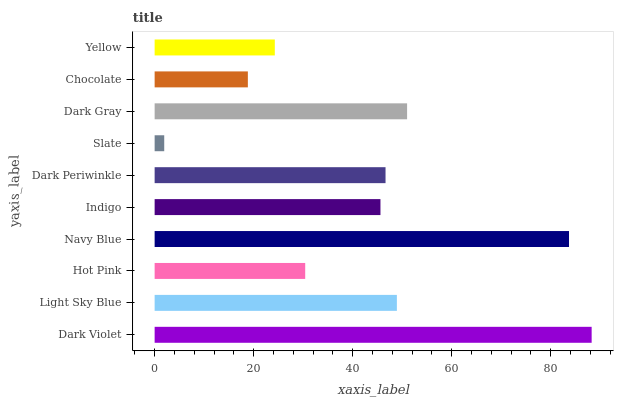Is Slate the minimum?
Answer yes or no. Yes. Is Dark Violet the maximum?
Answer yes or no. Yes. Is Light Sky Blue the minimum?
Answer yes or no. No. Is Light Sky Blue the maximum?
Answer yes or no. No. Is Dark Violet greater than Light Sky Blue?
Answer yes or no. Yes. Is Light Sky Blue less than Dark Violet?
Answer yes or no. Yes. Is Light Sky Blue greater than Dark Violet?
Answer yes or no. No. Is Dark Violet less than Light Sky Blue?
Answer yes or no. No. Is Dark Periwinkle the high median?
Answer yes or no. Yes. Is Indigo the low median?
Answer yes or no. Yes. Is Slate the high median?
Answer yes or no. No. Is Slate the low median?
Answer yes or no. No. 